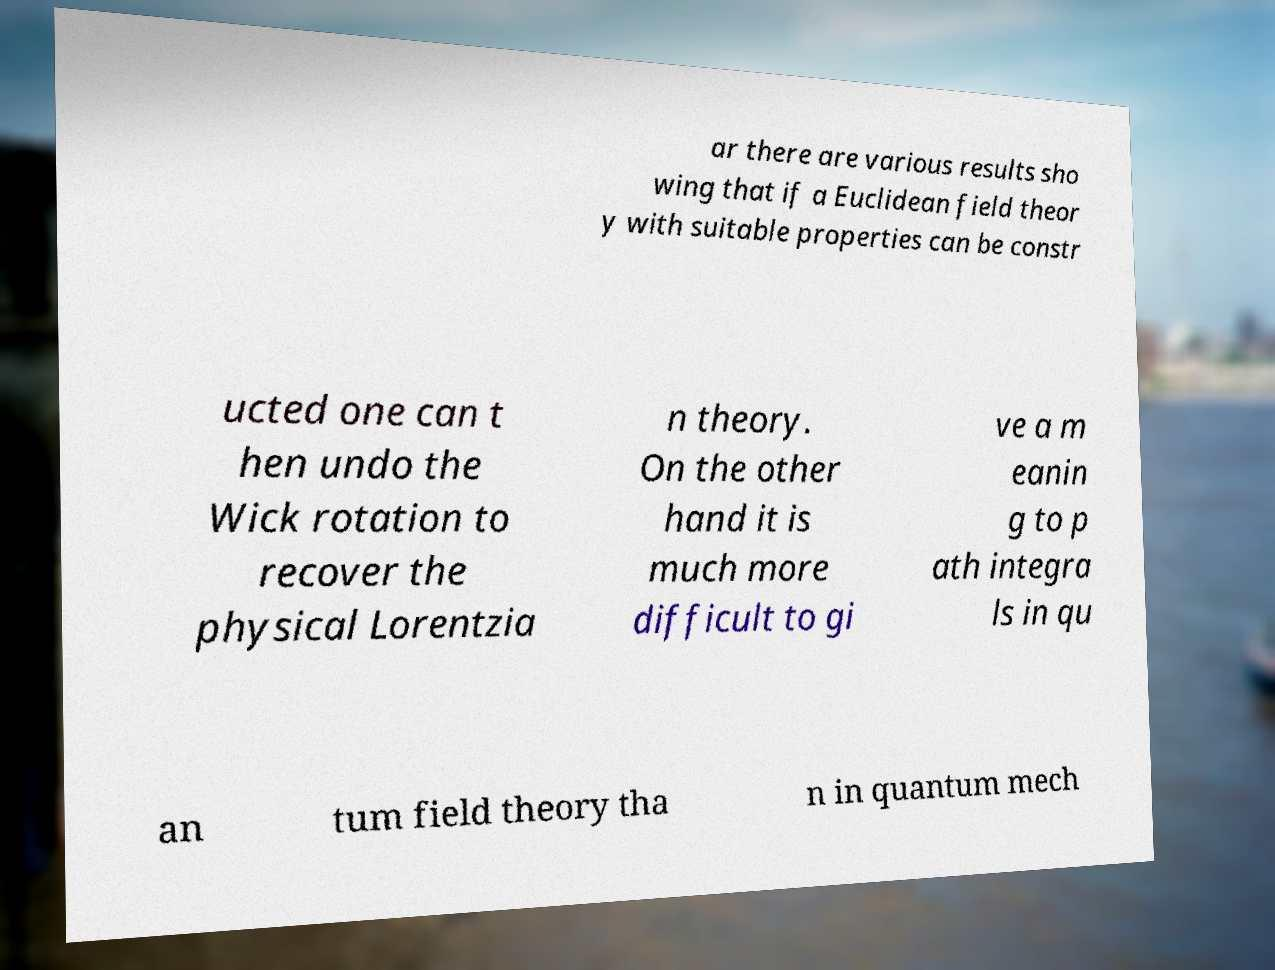Can you accurately transcribe the text from the provided image for me? ar there are various results sho wing that if a Euclidean field theor y with suitable properties can be constr ucted one can t hen undo the Wick rotation to recover the physical Lorentzia n theory. On the other hand it is much more difficult to gi ve a m eanin g to p ath integra ls in qu an tum field theory tha n in quantum mech 